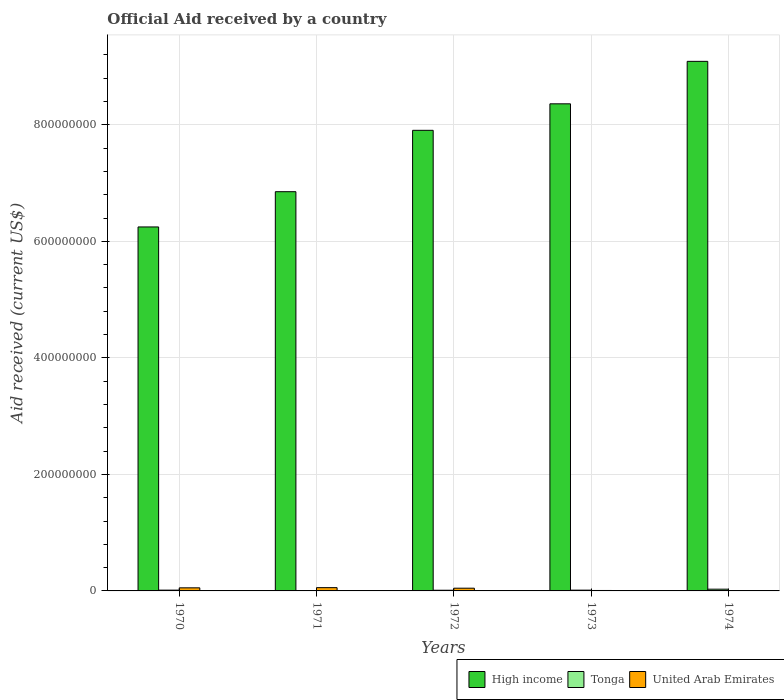How many different coloured bars are there?
Your answer should be compact. 3. Are the number of bars per tick equal to the number of legend labels?
Your response must be concise. Yes. Are the number of bars on each tick of the X-axis equal?
Provide a succinct answer. Yes. How many bars are there on the 5th tick from the left?
Your response must be concise. 3. What is the label of the 5th group of bars from the left?
Your answer should be compact. 1974. In how many cases, is the number of bars for a given year not equal to the number of legend labels?
Provide a short and direct response. 0. What is the net official aid received in United Arab Emirates in 1971?
Provide a short and direct response. 5.61e+06. Across all years, what is the maximum net official aid received in High income?
Provide a succinct answer. 9.09e+08. Across all years, what is the minimum net official aid received in High income?
Your answer should be very brief. 6.25e+08. In which year was the net official aid received in United Arab Emirates maximum?
Make the answer very short. 1971. What is the total net official aid received in Tonga in the graph?
Keep it short and to the point. 7.57e+06. What is the difference between the net official aid received in High income in 1973 and that in 1974?
Ensure brevity in your answer.  -7.29e+07. What is the difference between the net official aid received in Tonga in 1973 and the net official aid received in High income in 1971?
Offer a terse response. -6.84e+08. What is the average net official aid received in Tonga per year?
Your answer should be compact. 1.51e+06. In the year 1971, what is the difference between the net official aid received in High income and net official aid received in United Arab Emirates?
Provide a succinct answer. 6.80e+08. In how many years, is the net official aid received in Tonga greater than 280000000 US$?
Provide a succinct answer. 0. What is the ratio of the net official aid received in United Arab Emirates in 1970 to that in 1972?
Keep it short and to the point. 1.13. What is the difference between the highest and the second highest net official aid received in High income?
Give a very brief answer. 7.29e+07. What is the difference between the highest and the lowest net official aid received in United Arab Emirates?
Your answer should be compact. 5.02e+06. In how many years, is the net official aid received in High income greater than the average net official aid received in High income taken over all years?
Make the answer very short. 3. Is the sum of the net official aid received in High income in 1972 and 1973 greater than the maximum net official aid received in United Arab Emirates across all years?
Offer a very short reply. Yes. What does the 1st bar from the left in 1972 represents?
Your answer should be very brief. High income. What does the 3rd bar from the right in 1971 represents?
Make the answer very short. High income. How many bars are there?
Your answer should be compact. 15. How many years are there in the graph?
Your response must be concise. 5. What is the difference between two consecutive major ticks on the Y-axis?
Your answer should be compact. 2.00e+08. How are the legend labels stacked?
Ensure brevity in your answer.  Horizontal. What is the title of the graph?
Give a very brief answer. Official Aid received by a country. What is the label or title of the Y-axis?
Your response must be concise. Aid received (current US$). What is the Aid received (current US$) of High income in 1970?
Provide a succinct answer. 6.25e+08. What is the Aid received (current US$) in Tonga in 1970?
Make the answer very short. 1.35e+06. What is the Aid received (current US$) in United Arab Emirates in 1970?
Keep it short and to the point. 5.29e+06. What is the Aid received (current US$) of High income in 1971?
Offer a terse response. 6.85e+08. What is the Aid received (current US$) in Tonga in 1971?
Your answer should be very brief. 7.10e+05. What is the Aid received (current US$) of United Arab Emirates in 1971?
Your answer should be compact. 5.61e+06. What is the Aid received (current US$) in High income in 1972?
Ensure brevity in your answer.  7.91e+08. What is the Aid received (current US$) in Tonga in 1972?
Your response must be concise. 1.17e+06. What is the Aid received (current US$) in United Arab Emirates in 1972?
Keep it short and to the point. 4.68e+06. What is the Aid received (current US$) in High income in 1973?
Make the answer very short. 8.36e+08. What is the Aid received (current US$) in Tonga in 1973?
Your response must be concise. 1.34e+06. What is the Aid received (current US$) of United Arab Emirates in 1973?
Offer a terse response. 7.60e+05. What is the Aid received (current US$) in High income in 1974?
Offer a terse response. 9.09e+08. What is the Aid received (current US$) in United Arab Emirates in 1974?
Make the answer very short. 5.90e+05. Across all years, what is the maximum Aid received (current US$) of High income?
Offer a very short reply. 9.09e+08. Across all years, what is the maximum Aid received (current US$) of Tonga?
Make the answer very short. 3.00e+06. Across all years, what is the maximum Aid received (current US$) of United Arab Emirates?
Your response must be concise. 5.61e+06. Across all years, what is the minimum Aid received (current US$) in High income?
Your answer should be compact. 6.25e+08. Across all years, what is the minimum Aid received (current US$) in Tonga?
Offer a terse response. 7.10e+05. Across all years, what is the minimum Aid received (current US$) in United Arab Emirates?
Make the answer very short. 5.90e+05. What is the total Aid received (current US$) in High income in the graph?
Offer a very short reply. 3.85e+09. What is the total Aid received (current US$) in Tonga in the graph?
Give a very brief answer. 7.57e+06. What is the total Aid received (current US$) of United Arab Emirates in the graph?
Provide a succinct answer. 1.69e+07. What is the difference between the Aid received (current US$) of High income in 1970 and that in 1971?
Your response must be concise. -6.05e+07. What is the difference between the Aid received (current US$) in Tonga in 1970 and that in 1971?
Ensure brevity in your answer.  6.40e+05. What is the difference between the Aid received (current US$) of United Arab Emirates in 1970 and that in 1971?
Provide a succinct answer. -3.20e+05. What is the difference between the Aid received (current US$) in High income in 1970 and that in 1972?
Make the answer very short. -1.66e+08. What is the difference between the Aid received (current US$) in Tonga in 1970 and that in 1972?
Ensure brevity in your answer.  1.80e+05. What is the difference between the Aid received (current US$) in United Arab Emirates in 1970 and that in 1972?
Your response must be concise. 6.10e+05. What is the difference between the Aid received (current US$) of High income in 1970 and that in 1973?
Give a very brief answer. -2.11e+08. What is the difference between the Aid received (current US$) of United Arab Emirates in 1970 and that in 1973?
Your answer should be very brief. 4.53e+06. What is the difference between the Aid received (current US$) in High income in 1970 and that in 1974?
Provide a short and direct response. -2.84e+08. What is the difference between the Aid received (current US$) in Tonga in 1970 and that in 1974?
Keep it short and to the point. -1.65e+06. What is the difference between the Aid received (current US$) of United Arab Emirates in 1970 and that in 1974?
Provide a succinct answer. 4.70e+06. What is the difference between the Aid received (current US$) in High income in 1971 and that in 1972?
Give a very brief answer. -1.05e+08. What is the difference between the Aid received (current US$) of Tonga in 1971 and that in 1972?
Give a very brief answer. -4.60e+05. What is the difference between the Aid received (current US$) in United Arab Emirates in 1971 and that in 1972?
Your answer should be compact. 9.30e+05. What is the difference between the Aid received (current US$) in High income in 1971 and that in 1973?
Your answer should be compact. -1.51e+08. What is the difference between the Aid received (current US$) in Tonga in 1971 and that in 1973?
Offer a terse response. -6.30e+05. What is the difference between the Aid received (current US$) of United Arab Emirates in 1971 and that in 1973?
Offer a terse response. 4.85e+06. What is the difference between the Aid received (current US$) of High income in 1971 and that in 1974?
Provide a succinct answer. -2.24e+08. What is the difference between the Aid received (current US$) of Tonga in 1971 and that in 1974?
Keep it short and to the point. -2.29e+06. What is the difference between the Aid received (current US$) of United Arab Emirates in 1971 and that in 1974?
Provide a succinct answer. 5.02e+06. What is the difference between the Aid received (current US$) of High income in 1972 and that in 1973?
Ensure brevity in your answer.  -4.55e+07. What is the difference between the Aid received (current US$) of United Arab Emirates in 1972 and that in 1973?
Make the answer very short. 3.92e+06. What is the difference between the Aid received (current US$) of High income in 1972 and that in 1974?
Provide a succinct answer. -1.18e+08. What is the difference between the Aid received (current US$) in Tonga in 1972 and that in 1974?
Your answer should be compact. -1.83e+06. What is the difference between the Aid received (current US$) of United Arab Emirates in 1972 and that in 1974?
Provide a short and direct response. 4.09e+06. What is the difference between the Aid received (current US$) of High income in 1973 and that in 1974?
Ensure brevity in your answer.  -7.29e+07. What is the difference between the Aid received (current US$) in Tonga in 1973 and that in 1974?
Offer a very short reply. -1.66e+06. What is the difference between the Aid received (current US$) of United Arab Emirates in 1973 and that in 1974?
Your answer should be very brief. 1.70e+05. What is the difference between the Aid received (current US$) in High income in 1970 and the Aid received (current US$) in Tonga in 1971?
Offer a terse response. 6.24e+08. What is the difference between the Aid received (current US$) of High income in 1970 and the Aid received (current US$) of United Arab Emirates in 1971?
Make the answer very short. 6.19e+08. What is the difference between the Aid received (current US$) of Tonga in 1970 and the Aid received (current US$) of United Arab Emirates in 1971?
Give a very brief answer. -4.26e+06. What is the difference between the Aid received (current US$) of High income in 1970 and the Aid received (current US$) of Tonga in 1972?
Make the answer very short. 6.24e+08. What is the difference between the Aid received (current US$) of High income in 1970 and the Aid received (current US$) of United Arab Emirates in 1972?
Your answer should be very brief. 6.20e+08. What is the difference between the Aid received (current US$) in Tonga in 1970 and the Aid received (current US$) in United Arab Emirates in 1972?
Your answer should be very brief. -3.33e+06. What is the difference between the Aid received (current US$) in High income in 1970 and the Aid received (current US$) in Tonga in 1973?
Your answer should be compact. 6.23e+08. What is the difference between the Aid received (current US$) of High income in 1970 and the Aid received (current US$) of United Arab Emirates in 1973?
Provide a short and direct response. 6.24e+08. What is the difference between the Aid received (current US$) of Tonga in 1970 and the Aid received (current US$) of United Arab Emirates in 1973?
Your answer should be compact. 5.90e+05. What is the difference between the Aid received (current US$) in High income in 1970 and the Aid received (current US$) in Tonga in 1974?
Provide a succinct answer. 6.22e+08. What is the difference between the Aid received (current US$) of High income in 1970 and the Aid received (current US$) of United Arab Emirates in 1974?
Make the answer very short. 6.24e+08. What is the difference between the Aid received (current US$) of Tonga in 1970 and the Aid received (current US$) of United Arab Emirates in 1974?
Keep it short and to the point. 7.60e+05. What is the difference between the Aid received (current US$) in High income in 1971 and the Aid received (current US$) in Tonga in 1972?
Your answer should be compact. 6.84e+08. What is the difference between the Aid received (current US$) of High income in 1971 and the Aid received (current US$) of United Arab Emirates in 1972?
Offer a terse response. 6.81e+08. What is the difference between the Aid received (current US$) in Tonga in 1971 and the Aid received (current US$) in United Arab Emirates in 1972?
Keep it short and to the point. -3.97e+06. What is the difference between the Aid received (current US$) in High income in 1971 and the Aid received (current US$) in Tonga in 1973?
Provide a short and direct response. 6.84e+08. What is the difference between the Aid received (current US$) of High income in 1971 and the Aid received (current US$) of United Arab Emirates in 1973?
Provide a short and direct response. 6.85e+08. What is the difference between the Aid received (current US$) of Tonga in 1971 and the Aid received (current US$) of United Arab Emirates in 1973?
Make the answer very short. -5.00e+04. What is the difference between the Aid received (current US$) of High income in 1971 and the Aid received (current US$) of Tonga in 1974?
Your answer should be very brief. 6.82e+08. What is the difference between the Aid received (current US$) in High income in 1971 and the Aid received (current US$) in United Arab Emirates in 1974?
Provide a short and direct response. 6.85e+08. What is the difference between the Aid received (current US$) of High income in 1972 and the Aid received (current US$) of Tonga in 1973?
Ensure brevity in your answer.  7.89e+08. What is the difference between the Aid received (current US$) in High income in 1972 and the Aid received (current US$) in United Arab Emirates in 1973?
Offer a terse response. 7.90e+08. What is the difference between the Aid received (current US$) of Tonga in 1972 and the Aid received (current US$) of United Arab Emirates in 1973?
Your answer should be very brief. 4.10e+05. What is the difference between the Aid received (current US$) in High income in 1972 and the Aid received (current US$) in Tonga in 1974?
Keep it short and to the point. 7.88e+08. What is the difference between the Aid received (current US$) of High income in 1972 and the Aid received (current US$) of United Arab Emirates in 1974?
Keep it short and to the point. 7.90e+08. What is the difference between the Aid received (current US$) in Tonga in 1972 and the Aid received (current US$) in United Arab Emirates in 1974?
Your answer should be very brief. 5.80e+05. What is the difference between the Aid received (current US$) of High income in 1973 and the Aid received (current US$) of Tonga in 1974?
Give a very brief answer. 8.33e+08. What is the difference between the Aid received (current US$) in High income in 1973 and the Aid received (current US$) in United Arab Emirates in 1974?
Keep it short and to the point. 8.36e+08. What is the difference between the Aid received (current US$) of Tonga in 1973 and the Aid received (current US$) of United Arab Emirates in 1974?
Make the answer very short. 7.50e+05. What is the average Aid received (current US$) of High income per year?
Ensure brevity in your answer.  7.69e+08. What is the average Aid received (current US$) in Tonga per year?
Offer a terse response. 1.51e+06. What is the average Aid received (current US$) in United Arab Emirates per year?
Your response must be concise. 3.39e+06. In the year 1970, what is the difference between the Aid received (current US$) in High income and Aid received (current US$) in Tonga?
Keep it short and to the point. 6.23e+08. In the year 1970, what is the difference between the Aid received (current US$) of High income and Aid received (current US$) of United Arab Emirates?
Offer a very short reply. 6.20e+08. In the year 1970, what is the difference between the Aid received (current US$) in Tonga and Aid received (current US$) in United Arab Emirates?
Ensure brevity in your answer.  -3.94e+06. In the year 1971, what is the difference between the Aid received (current US$) in High income and Aid received (current US$) in Tonga?
Keep it short and to the point. 6.85e+08. In the year 1971, what is the difference between the Aid received (current US$) in High income and Aid received (current US$) in United Arab Emirates?
Your answer should be compact. 6.80e+08. In the year 1971, what is the difference between the Aid received (current US$) of Tonga and Aid received (current US$) of United Arab Emirates?
Your answer should be compact. -4.90e+06. In the year 1972, what is the difference between the Aid received (current US$) in High income and Aid received (current US$) in Tonga?
Your answer should be compact. 7.90e+08. In the year 1972, what is the difference between the Aid received (current US$) of High income and Aid received (current US$) of United Arab Emirates?
Your response must be concise. 7.86e+08. In the year 1972, what is the difference between the Aid received (current US$) in Tonga and Aid received (current US$) in United Arab Emirates?
Your answer should be very brief. -3.51e+06. In the year 1973, what is the difference between the Aid received (current US$) in High income and Aid received (current US$) in Tonga?
Ensure brevity in your answer.  8.35e+08. In the year 1973, what is the difference between the Aid received (current US$) in High income and Aid received (current US$) in United Arab Emirates?
Provide a short and direct response. 8.35e+08. In the year 1973, what is the difference between the Aid received (current US$) in Tonga and Aid received (current US$) in United Arab Emirates?
Offer a terse response. 5.80e+05. In the year 1974, what is the difference between the Aid received (current US$) of High income and Aid received (current US$) of Tonga?
Make the answer very short. 9.06e+08. In the year 1974, what is the difference between the Aid received (current US$) in High income and Aid received (current US$) in United Arab Emirates?
Provide a succinct answer. 9.08e+08. In the year 1974, what is the difference between the Aid received (current US$) in Tonga and Aid received (current US$) in United Arab Emirates?
Make the answer very short. 2.41e+06. What is the ratio of the Aid received (current US$) of High income in 1970 to that in 1971?
Provide a succinct answer. 0.91. What is the ratio of the Aid received (current US$) in Tonga in 1970 to that in 1971?
Offer a very short reply. 1.9. What is the ratio of the Aid received (current US$) of United Arab Emirates in 1970 to that in 1971?
Offer a terse response. 0.94. What is the ratio of the Aid received (current US$) in High income in 1970 to that in 1972?
Ensure brevity in your answer.  0.79. What is the ratio of the Aid received (current US$) of Tonga in 1970 to that in 1972?
Give a very brief answer. 1.15. What is the ratio of the Aid received (current US$) of United Arab Emirates in 1970 to that in 1972?
Make the answer very short. 1.13. What is the ratio of the Aid received (current US$) in High income in 1970 to that in 1973?
Give a very brief answer. 0.75. What is the ratio of the Aid received (current US$) in Tonga in 1970 to that in 1973?
Your answer should be compact. 1.01. What is the ratio of the Aid received (current US$) of United Arab Emirates in 1970 to that in 1973?
Offer a terse response. 6.96. What is the ratio of the Aid received (current US$) in High income in 1970 to that in 1974?
Provide a succinct answer. 0.69. What is the ratio of the Aid received (current US$) in Tonga in 1970 to that in 1974?
Keep it short and to the point. 0.45. What is the ratio of the Aid received (current US$) of United Arab Emirates in 1970 to that in 1974?
Offer a very short reply. 8.97. What is the ratio of the Aid received (current US$) in High income in 1971 to that in 1972?
Provide a succinct answer. 0.87. What is the ratio of the Aid received (current US$) of Tonga in 1971 to that in 1972?
Offer a very short reply. 0.61. What is the ratio of the Aid received (current US$) in United Arab Emirates in 1971 to that in 1972?
Your answer should be compact. 1.2. What is the ratio of the Aid received (current US$) of High income in 1971 to that in 1973?
Offer a terse response. 0.82. What is the ratio of the Aid received (current US$) in Tonga in 1971 to that in 1973?
Give a very brief answer. 0.53. What is the ratio of the Aid received (current US$) of United Arab Emirates in 1971 to that in 1973?
Make the answer very short. 7.38. What is the ratio of the Aid received (current US$) in High income in 1971 to that in 1974?
Ensure brevity in your answer.  0.75. What is the ratio of the Aid received (current US$) in Tonga in 1971 to that in 1974?
Your response must be concise. 0.24. What is the ratio of the Aid received (current US$) of United Arab Emirates in 1971 to that in 1974?
Make the answer very short. 9.51. What is the ratio of the Aid received (current US$) of High income in 1972 to that in 1973?
Provide a short and direct response. 0.95. What is the ratio of the Aid received (current US$) in Tonga in 1972 to that in 1973?
Keep it short and to the point. 0.87. What is the ratio of the Aid received (current US$) in United Arab Emirates in 1972 to that in 1973?
Your response must be concise. 6.16. What is the ratio of the Aid received (current US$) of High income in 1972 to that in 1974?
Provide a succinct answer. 0.87. What is the ratio of the Aid received (current US$) in Tonga in 1972 to that in 1974?
Provide a succinct answer. 0.39. What is the ratio of the Aid received (current US$) in United Arab Emirates in 1972 to that in 1974?
Your response must be concise. 7.93. What is the ratio of the Aid received (current US$) of High income in 1973 to that in 1974?
Your answer should be compact. 0.92. What is the ratio of the Aid received (current US$) in Tonga in 1973 to that in 1974?
Your response must be concise. 0.45. What is the ratio of the Aid received (current US$) in United Arab Emirates in 1973 to that in 1974?
Your response must be concise. 1.29. What is the difference between the highest and the second highest Aid received (current US$) in High income?
Provide a succinct answer. 7.29e+07. What is the difference between the highest and the second highest Aid received (current US$) in Tonga?
Your answer should be compact. 1.65e+06. What is the difference between the highest and the lowest Aid received (current US$) in High income?
Your answer should be compact. 2.84e+08. What is the difference between the highest and the lowest Aid received (current US$) of Tonga?
Offer a terse response. 2.29e+06. What is the difference between the highest and the lowest Aid received (current US$) of United Arab Emirates?
Make the answer very short. 5.02e+06. 